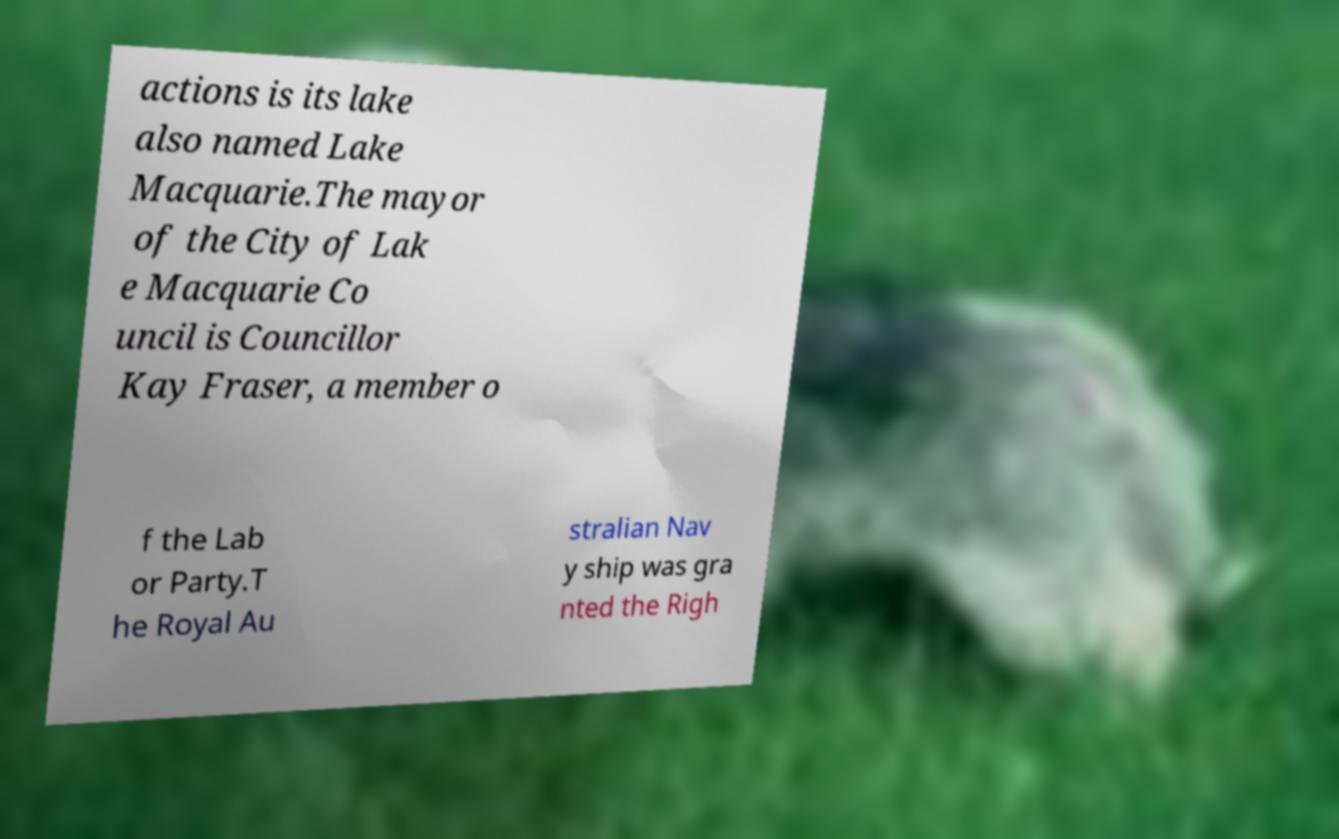Could you assist in decoding the text presented in this image and type it out clearly? actions is its lake also named Lake Macquarie.The mayor of the City of Lak e Macquarie Co uncil is Councillor Kay Fraser, a member o f the Lab or Party.T he Royal Au stralian Nav y ship was gra nted the Righ 